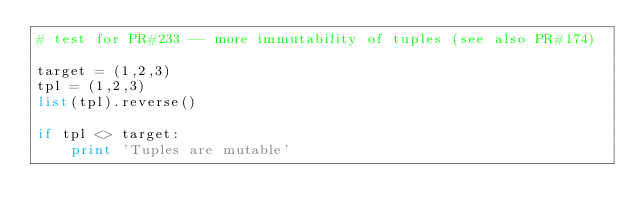Convert code to text. <code><loc_0><loc_0><loc_500><loc_500><_Python_># test for PR#233 -- more immutability of tuples (see also PR#174)

target = (1,2,3)
tpl = (1,2,3)
list(tpl).reverse()

if tpl <> target:
    print 'Tuples are mutable'
</code> 